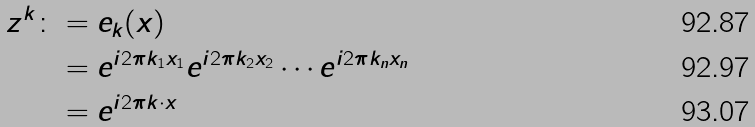<formula> <loc_0><loc_0><loc_500><loc_500>z ^ { k } \colon & = e _ { k } ( x ) \\ & = e ^ { i 2 \pi k _ { 1 } x _ { 1 } } e ^ { i 2 \pi k _ { 2 } x _ { 2 } } \cdots e ^ { i 2 \pi k _ { n } x _ { n } } \\ & = e ^ { i 2 \pi k \cdot x }</formula> 